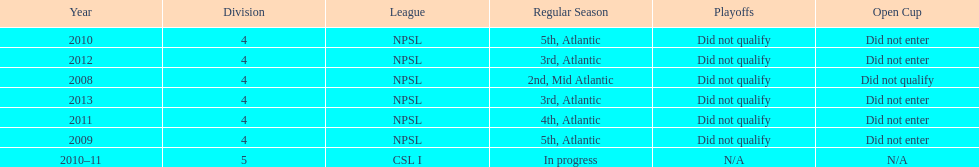Using the data, what should be the next year they will play? 2014. 